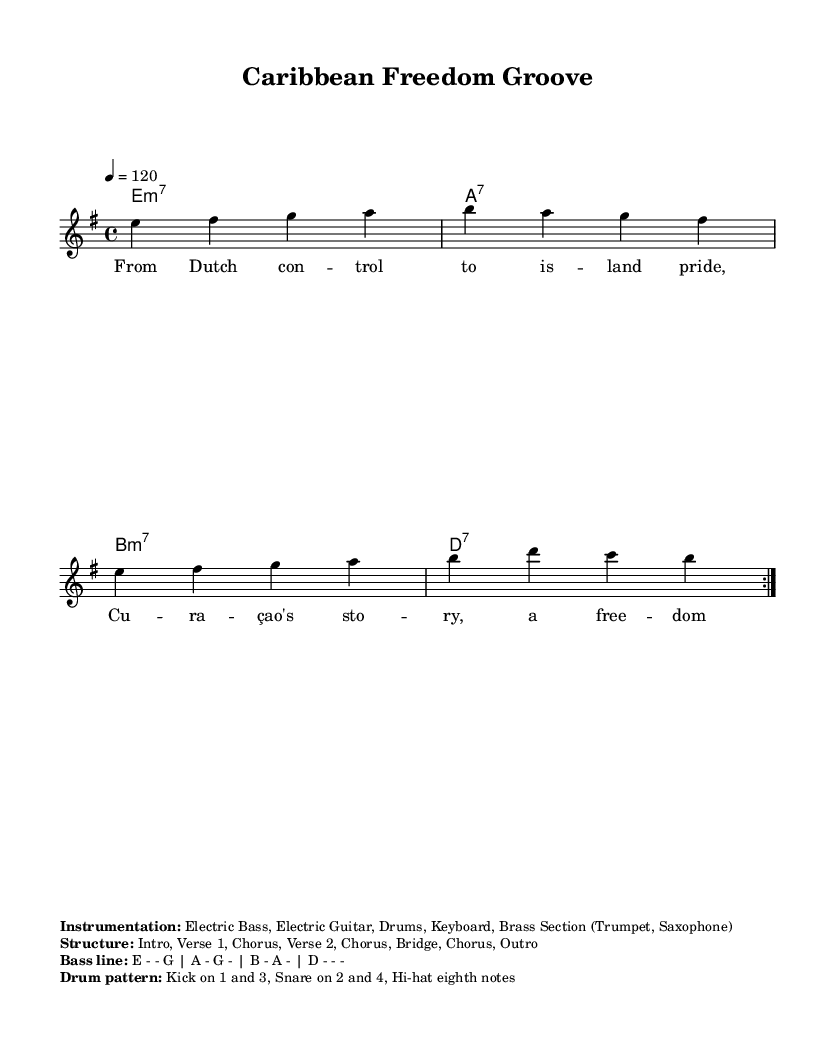What is the key signature of this music? The key signature is E minor, which has one sharp, indicated by the presence of the F# in the melody and chords.
Answer: E minor What is the time signature of this music? The time signature is indicated at the beginning of the score and shows that there are four beats per measure. The notation "4/4" confirms this.
Answer: 4/4 What is the tempo marking for this piece? The tempo is marked at the beginning of the score as "4 = 120", which indicates that there are 120 beats per minute.
Answer: 120 What is the structure of this piece? The structure is outlined clearly in the markup, and it lists the various sections in order: Intro, Verse 1, Chorus, Verse 2, Chorus, Bridge, Chorus, Outro.
Answer: Intro, Verse 1, Chorus, Verse 2, Chorus, Bridge, Chorus, Outro What instruments are used in this music? The instrumentation is specified in the markup section, detailing the types of instruments including Electric Bass, Electric Guitar, Drums, Keyboard, and a Brass Section.
Answer: Electric Bass, Electric Guitar, Drums, Keyboard, Brass Section Why is there a focus on colonial history in the lyrics? The lyrics reflect themes of colonial history and independence movements, which tie into the historical context of Curaçao, embodying a narrative of transformation and pride in overcoming colonial control. This deeper understanding comes from the lyrics' content which emphasizes local pride and freedom.
Answer: Colonial history and independence How does the bass line contribute to the funk genre? The bass line is characterized by a rhythmic groove that aligns with funk's signature style, where a strong, syncopated foundation supports the overall raw and vibrant feel of the genre, emphasizing the E, G, A, and D notes as driving elements in a repetitive pattern, typical for funk music.
Answer: Syncopated groove 